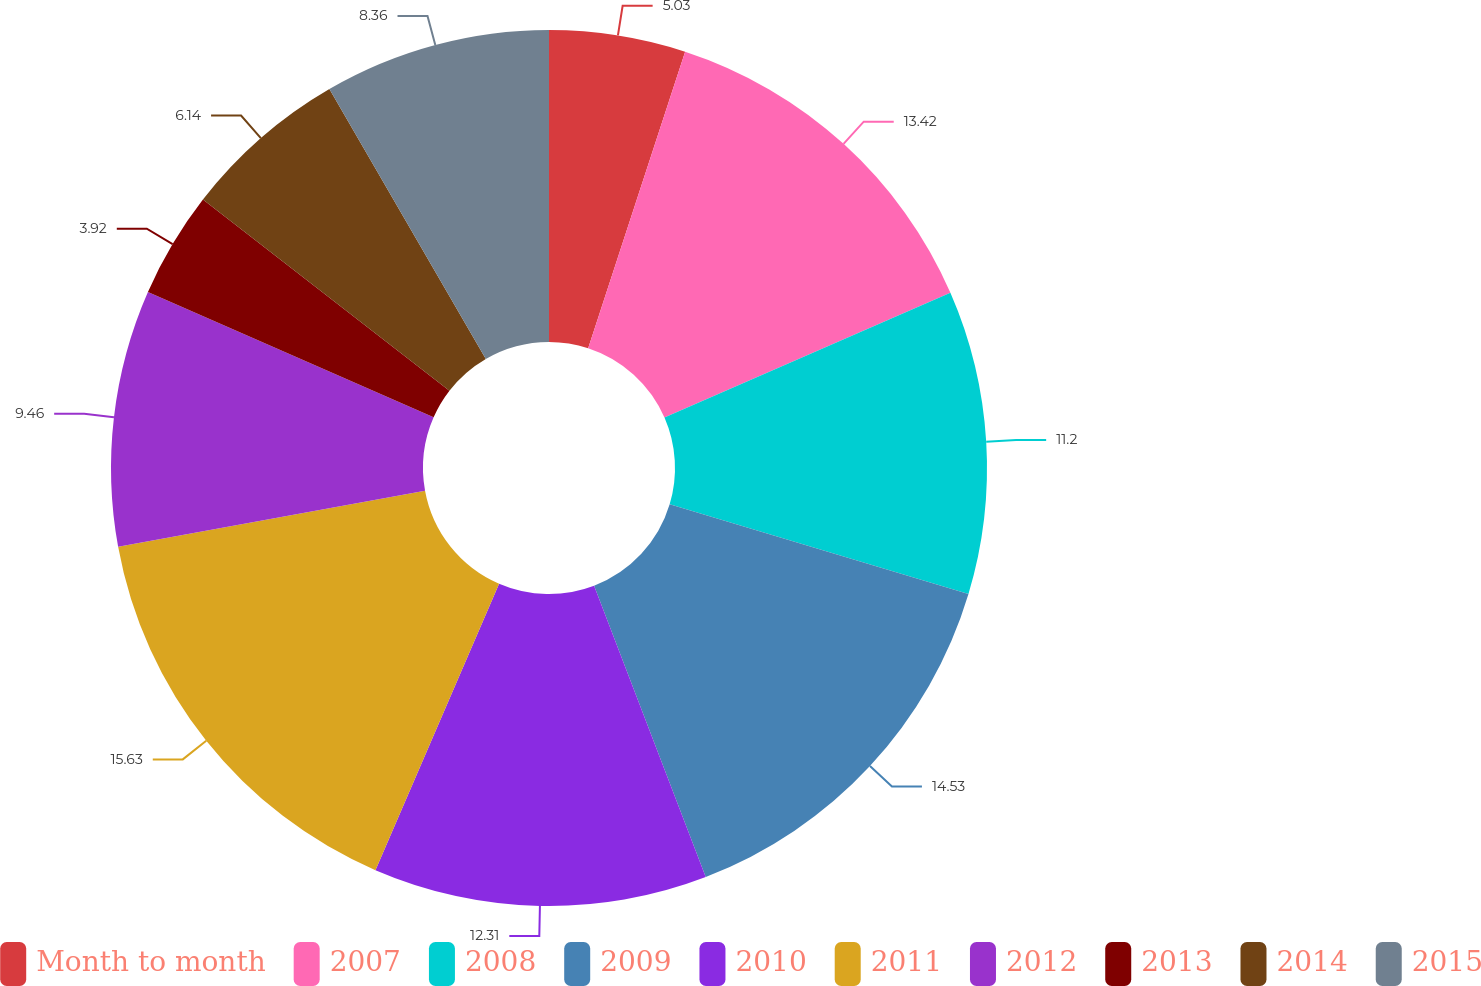Convert chart to OTSL. <chart><loc_0><loc_0><loc_500><loc_500><pie_chart><fcel>Month to month<fcel>2007<fcel>2008<fcel>2009<fcel>2010<fcel>2011<fcel>2012<fcel>2013<fcel>2014<fcel>2015<nl><fcel>5.03%<fcel>13.42%<fcel>11.2%<fcel>14.53%<fcel>12.31%<fcel>15.64%<fcel>9.46%<fcel>3.92%<fcel>6.14%<fcel>8.36%<nl></chart> 